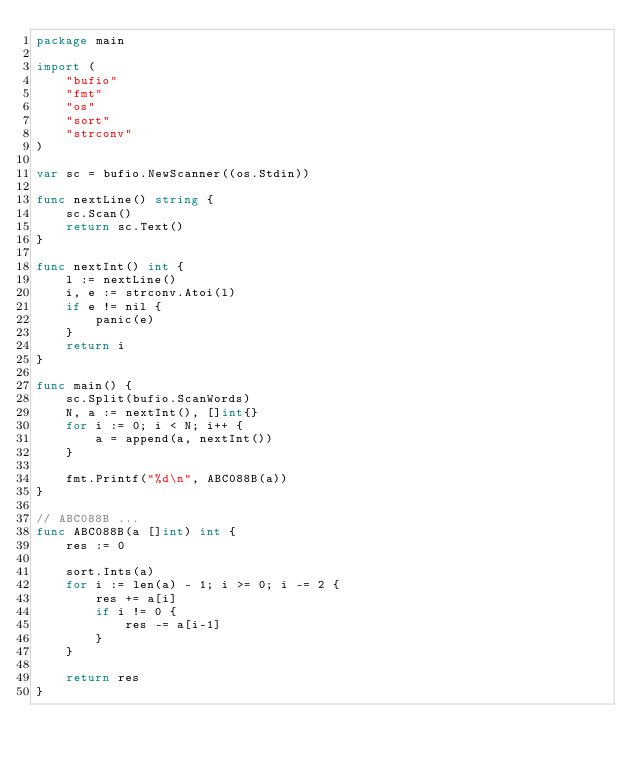Convert code to text. <code><loc_0><loc_0><loc_500><loc_500><_Go_>package main

import (
	"bufio"
	"fmt"
	"os"
	"sort"
	"strconv"
)

var sc = bufio.NewScanner((os.Stdin))

func nextLine() string {
	sc.Scan()
	return sc.Text()
}

func nextInt() int {
	l := nextLine()
	i, e := strconv.Atoi(l)
	if e != nil {
		panic(e)
	}
	return i
}

func main() {
	sc.Split(bufio.ScanWords)
	N, a := nextInt(), []int{}
	for i := 0; i < N; i++ {
		a = append(a, nextInt())
	}

	fmt.Printf("%d\n", ABC088B(a))
}

// ABC088B ...
func ABC088B(a []int) int {
	res := 0

	sort.Ints(a)
	for i := len(a) - 1; i >= 0; i -= 2 {
		res += a[i]
		if i != 0 {
			res -= a[i-1]
		}
	}

	return res
}
</code> 